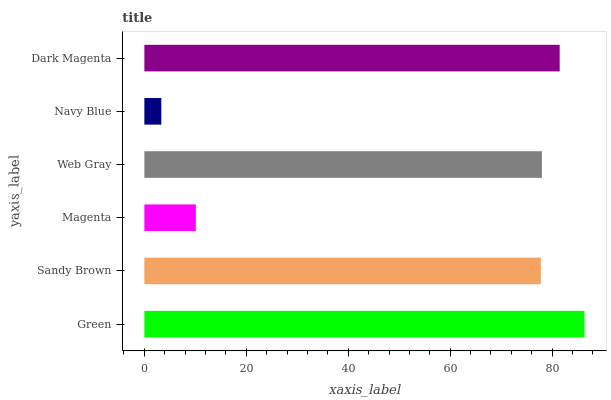Is Navy Blue the minimum?
Answer yes or no. Yes. Is Green the maximum?
Answer yes or no. Yes. Is Sandy Brown the minimum?
Answer yes or no. No. Is Sandy Brown the maximum?
Answer yes or no. No. Is Green greater than Sandy Brown?
Answer yes or no. Yes. Is Sandy Brown less than Green?
Answer yes or no. Yes. Is Sandy Brown greater than Green?
Answer yes or no. No. Is Green less than Sandy Brown?
Answer yes or no. No. Is Web Gray the high median?
Answer yes or no. Yes. Is Sandy Brown the low median?
Answer yes or no. Yes. Is Dark Magenta the high median?
Answer yes or no. No. Is Dark Magenta the low median?
Answer yes or no. No. 